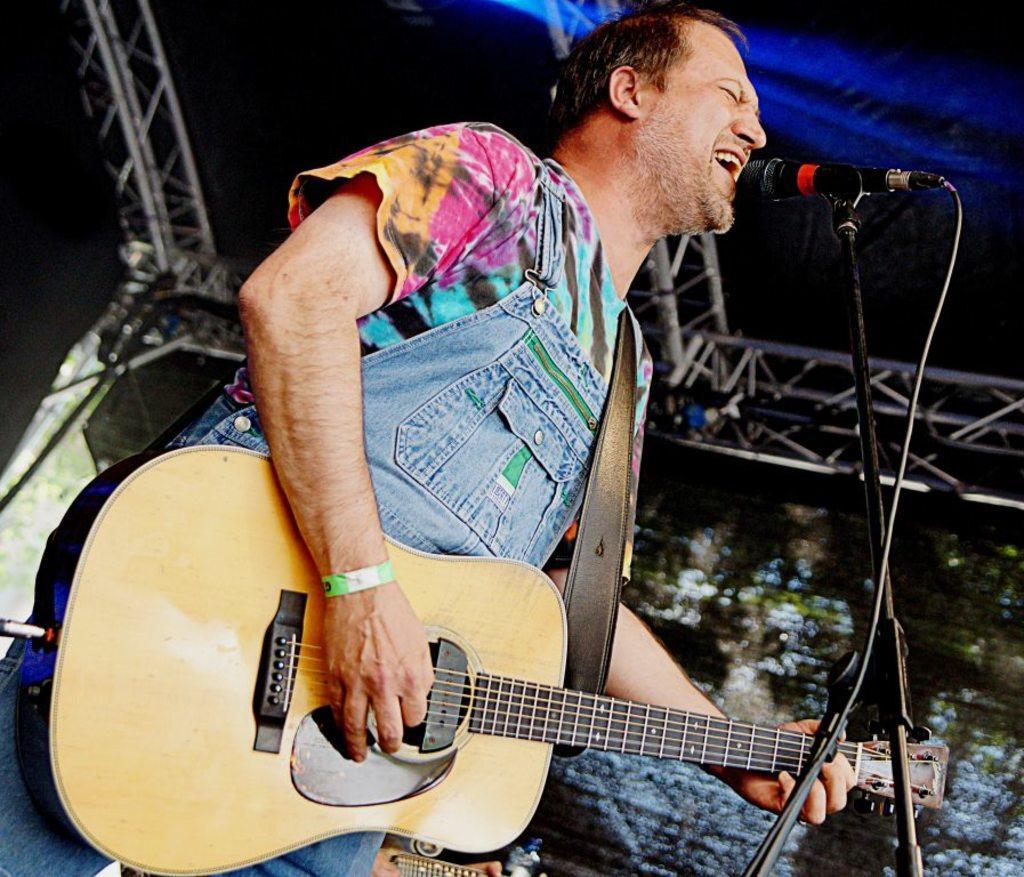How would you summarize this image in a sentence or two? Here we can see a man playing a guitar and singing a song with microphone in front of him 